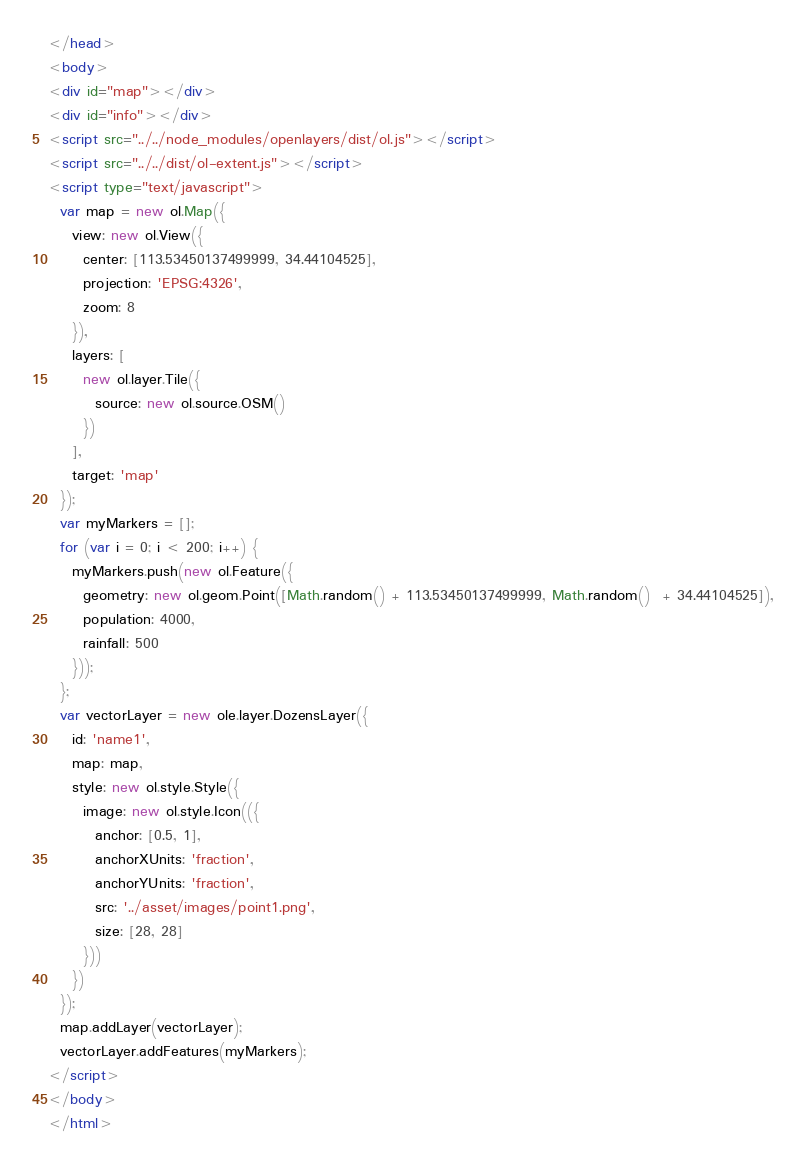Convert code to text. <code><loc_0><loc_0><loc_500><loc_500><_HTML_></head>
<body>
<div id="map"></div>
<div id="info"></div>
<script src="../../node_modules/openlayers/dist/ol.js"></script>
<script src="../../dist/ol-extent.js"></script>
<script type="text/javascript">
  var map = new ol.Map({
    view: new ol.View({
      center: [113.53450137499999, 34.44104525],
      projection: 'EPSG:4326',
      zoom: 8
    }),
    layers: [
      new ol.layer.Tile({
        source: new ol.source.OSM()
      })
    ],
    target: 'map'
  });
  var myMarkers = [];
  for (var i = 0; i < 200; i++) {
    myMarkers.push(new ol.Feature({
      geometry: new ol.geom.Point([Math.random() + 113.53450137499999, Math.random()  + 34.44104525]),
      population: 4000,
      rainfall: 500
    }));
  };
  var vectorLayer = new ole.layer.DozensLayer({
    id: 'name1',
    map: map,
    style: new ol.style.Style({
      image: new ol.style.Icon(({
        anchor: [0.5, 1],
        anchorXUnits: 'fraction',
        anchorYUnits: 'fraction',
        src: '../asset/images/point1.png',
        size: [28, 28]
      }))
    })
  });
  map.addLayer(vectorLayer);
  vectorLayer.addFeatures(myMarkers);
</script>
</body>
</html>
</code> 